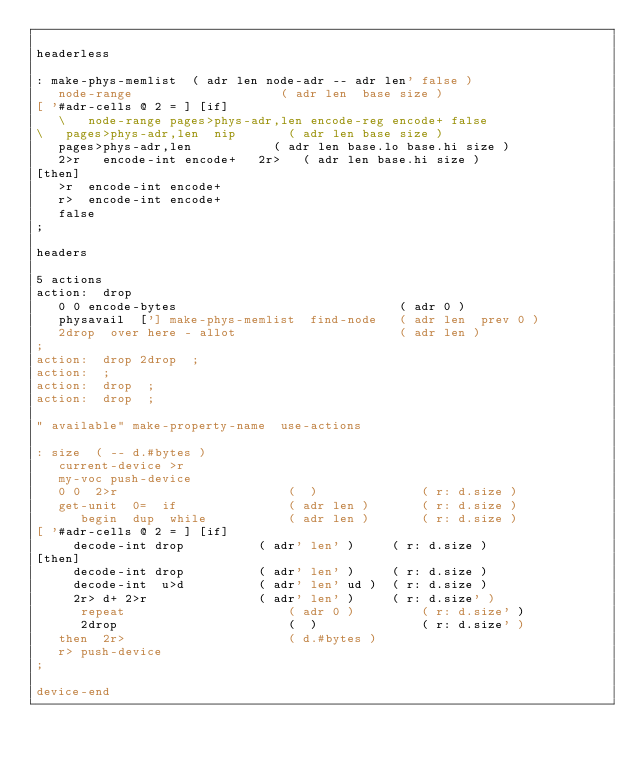<code> <loc_0><loc_0><loc_500><loc_500><_Forth_>
headerless

: make-phys-memlist  ( adr len node-adr -- adr len' false )
   node-range                    ( adr len  base size )
[ '#adr-cells @ 2 = ] [if]
   \   node-range pages>phys-adr,len encode-reg encode+ false
\   pages>phys-adr,len  nip       ( adr len base size )
   pages>phys-adr,len			( adr len base.lo base.hi size )
   2>r   encode-int encode+   2r>	( adr len base.hi size )
[then]
   >r  encode-int encode+
   r>  encode-int encode+
   false
;

headers

5 actions
action:  drop  
   0 0 encode-bytes                              ( adr 0 )
   physavail  ['] make-phys-memlist  find-node   ( adr len  prev 0 )
   2drop  over here - allot                      ( adr len )
;
action:  drop 2drop  ;
action:  ;
action:  drop  ;
action:  drop  ;

" available" make-property-name  use-actions

: size  ( -- d.#bytes )
   current-device >r
   my-voc push-device
   0 0  2>r                       (  )              ( r: d.size )
   get-unit  0=  if               ( adr len )       ( r: d.size )
      begin  dup  while           ( adr len )       ( r: d.size )
[ '#adr-cells @ 2 = ] [if]
	 decode-int drop          ( adr' len' )     ( r: d.size )
[then]
	 decode-int drop          ( adr' len' )     ( r: d.size )
	 decode-int  u>d          ( adr' len' ud )  ( r: d.size )
	 2r> d+ 2>r               ( adr' len' )     ( r: d.size' )
      repeat                      ( adr 0 )         ( r: d.size' )
      2drop                       (  )              ( r: d.size' )
   then  2r>                      ( d.#bytes )
   r> push-device
;

device-end
</code> 